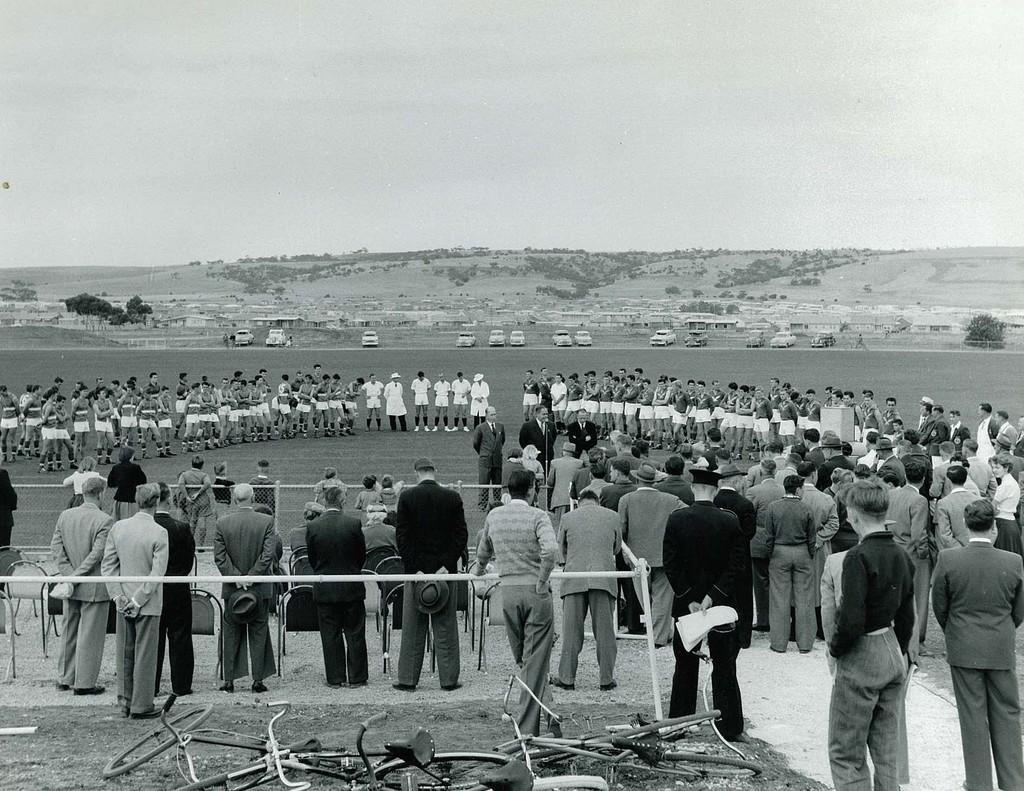Please provide a concise description of this image. A group of people are standing in the middle, few persons are standing, they wore white color dress. On the right side many people are standing and also on the left side. At the back side there are vehicles parked in this image. 